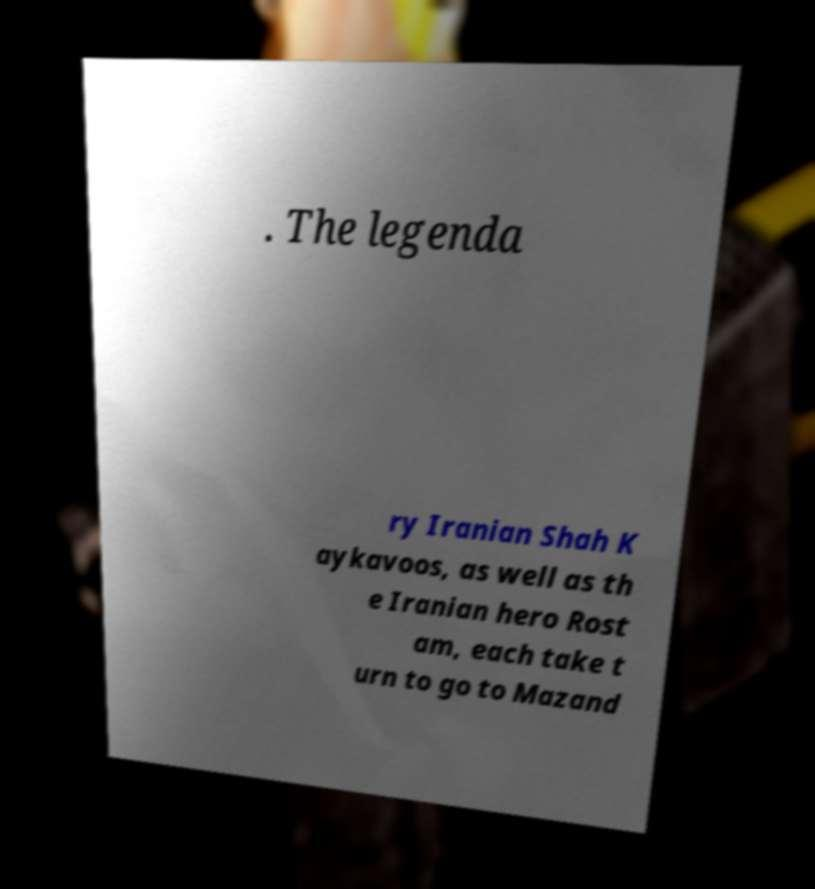Can you accurately transcribe the text from the provided image for me? . The legenda ry Iranian Shah K aykavoos, as well as th e Iranian hero Rost am, each take t urn to go to Mazand 